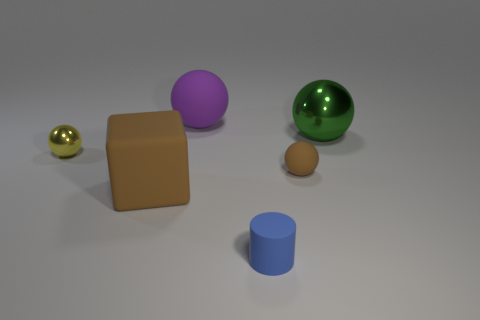There is a large thing in front of the small yellow metal sphere; is its color the same as the tiny rubber ball?
Your response must be concise. Yes. Do the small matte thing behind the large rubber block and the big rubber thing that is in front of the tiny matte ball have the same color?
Make the answer very short. Yes. Is there another small sphere made of the same material as the purple ball?
Give a very brief answer. Yes. How many green things are either large matte balls or metal things?
Your response must be concise. 1. Is the number of green objects behind the small metal ball greater than the number of red metal things?
Ensure brevity in your answer.  Yes. Does the purple object have the same size as the brown rubber ball?
Make the answer very short. No. What is the color of the small cylinder that is made of the same material as the brown cube?
Give a very brief answer. Blue. There is a small rubber object that is the same color as the large block; what shape is it?
Give a very brief answer. Sphere. Is the number of large metallic balls behind the large brown object the same as the number of tiny blue cylinders behind the big green metallic ball?
Provide a short and direct response. No. What is the shape of the purple rubber object that is behind the metal sphere on the right side of the tiny rubber ball?
Make the answer very short. Sphere. 